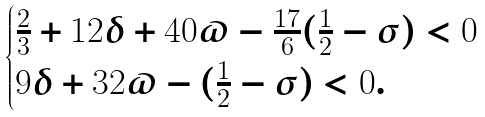<formula> <loc_0><loc_0><loc_500><loc_500>\begin{cases} \frac { 2 } { 3 } + 1 2 \delta + 4 0 \varpi - \frac { 1 7 } { 6 } ( \frac { 1 } { 2 } - \sigma ) < 0 \\ 9 \delta + 3 2 \varpi - ( \frac { 1 } { 2 } - \sigma ) < 0 . \end{cases}</formula> 